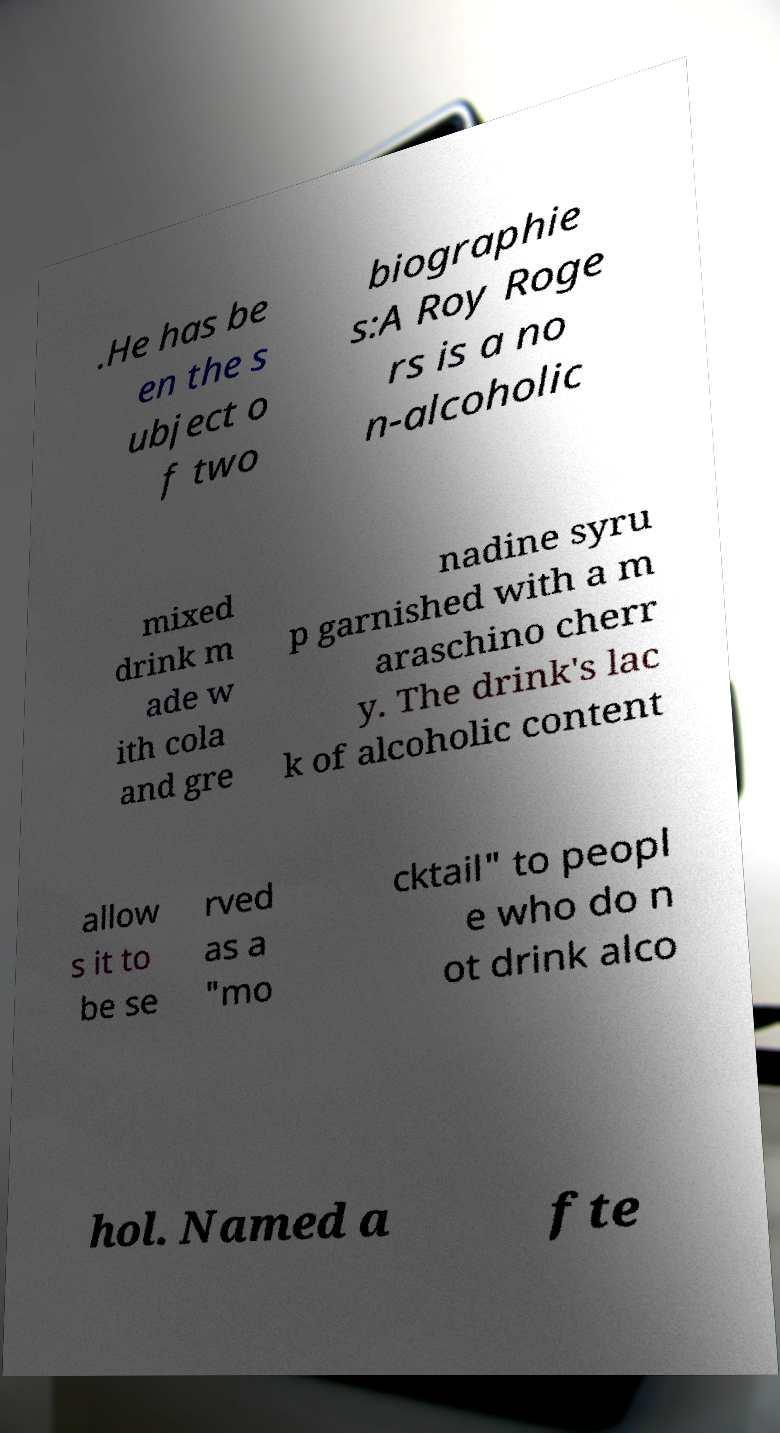Can you read and provide the text displayed in the image?This photo seems to have some interesting text. Can you extract and type it out for me? .He has be en the s ubject o f two biographie s:A Roy Roge rs is a no n-alcoholic mixed drink m ade w ith cola and gre nadine syru p garnished with a m araschino cherr y. The drink's lac k of alcoholic content allow s it to be se rved as a "mo cktail" to peopl e who do n ot drink alco hol. Named a fte 